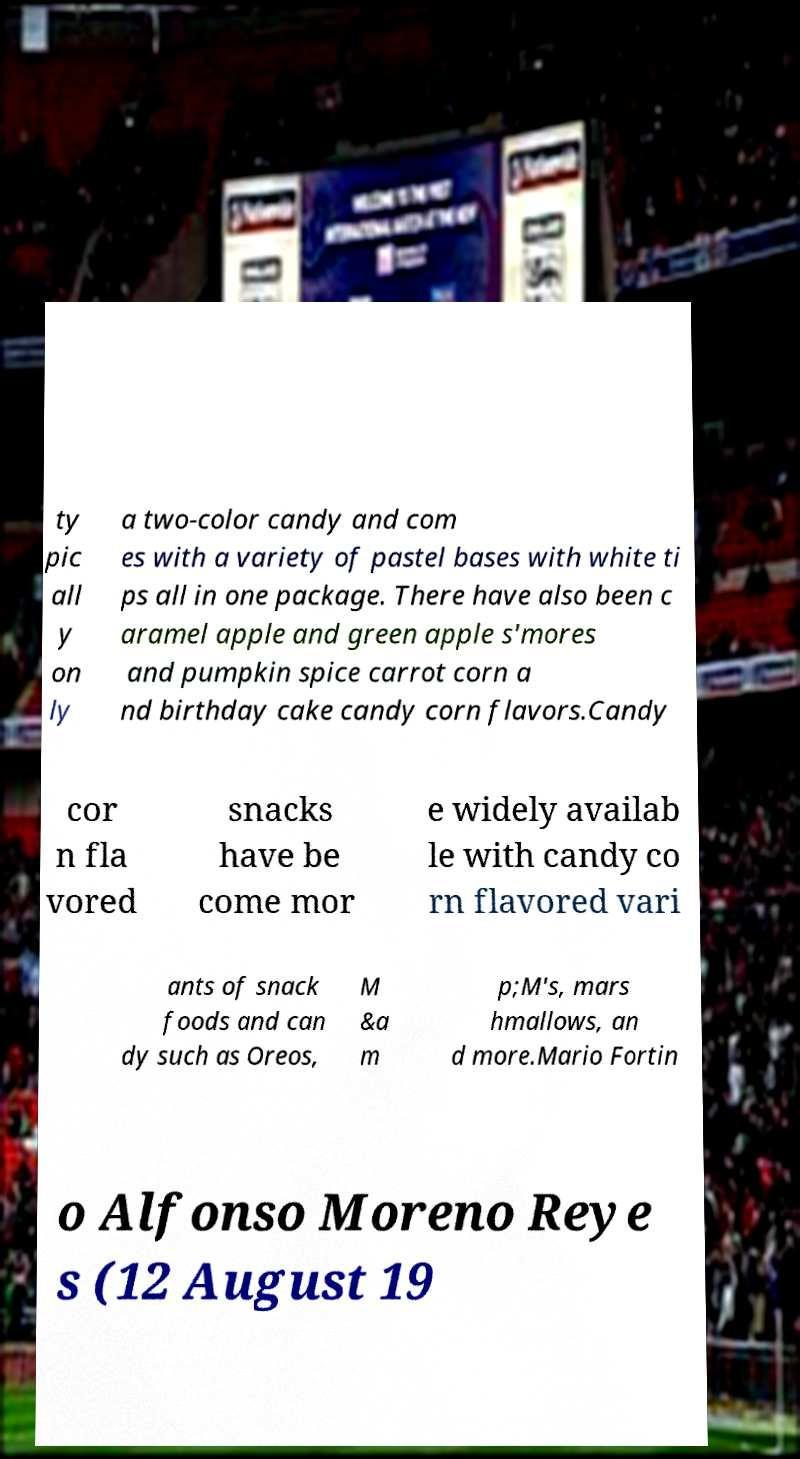Can you read and provide the text displayed in the image?This photo seems to have some interesting text. Can you extract and type it out for me? ty pic all y on ly a two-color candy and com es with a variety of pastel bases with white ti ps all in one package. There have also been c aramel apple and green apple s'mores and pumpkin spice carrot corn a nd birthday cake candy corn flavors.Candy cor n fla vored snacks have be come mor e widely availab le with candy co rn flavored vari ants of snack foods and can dy such as Oreos, M &a m p;M's, mars hmallows, an d more.Mario Fortin o Alfonso Moreno Reye s (12 August 19 